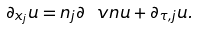Convert formula to latex. <formula><loc_0><loc_0><loc_500><loc_500>\partial _ { x _ { j } } u = n _ { j } \partial _ { \ } v n u + \partial _ { \tau , j } u .</formula> 